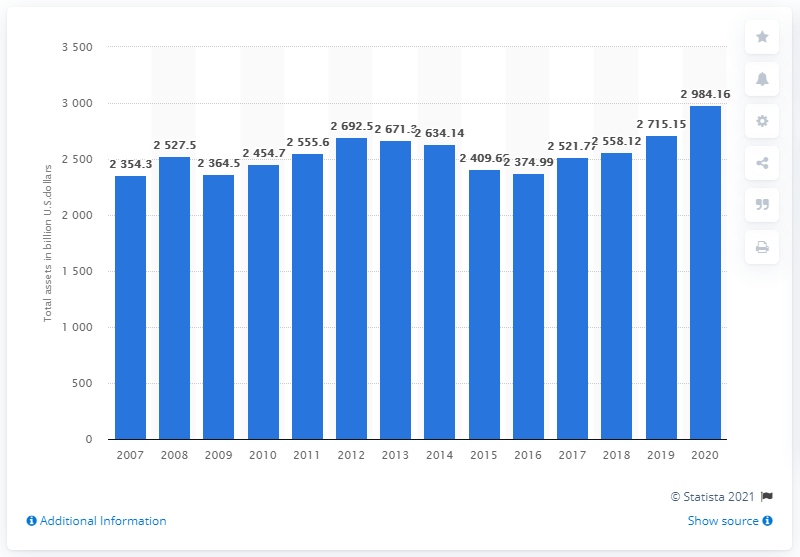Identify some key points in this picture. In 2020, the total assets of HSBC bank were approximately 2984.16 dollars. 